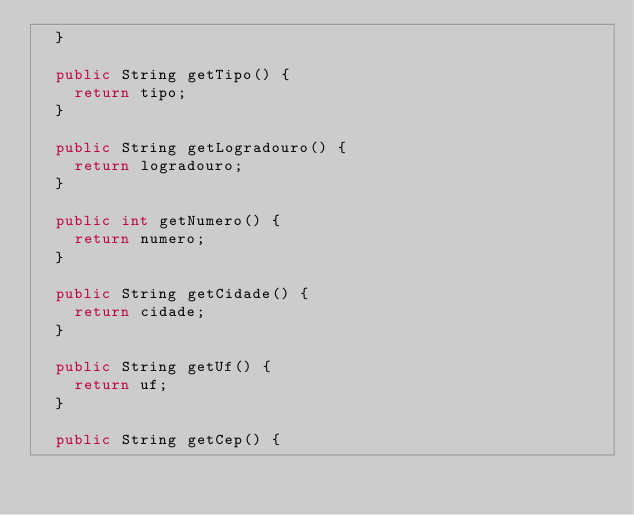Convert code to text. <code><loc_0><loc_0><loc_500><loc_500><_Java_>	}

	public String getTipo() {
		return tipo;
	}

	public String getLogradouro() {
		return logradouro;
	}

	public int getNumero() {
		return numero;
	}

	public String getCidade() {
		return cidade;
	}

	public String getUf() {
		return uf;
	}

	public String getCep() {</code> 